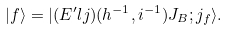<formula> <loc_0><loc_0><loc_500><loc_500>| f \rangle = | ( E ^ { \prime } l j ) ( h ^ { - 1 } , i ^ { - 1 } ) J _ { B } ; j _ { f } \rangle .</formula> 